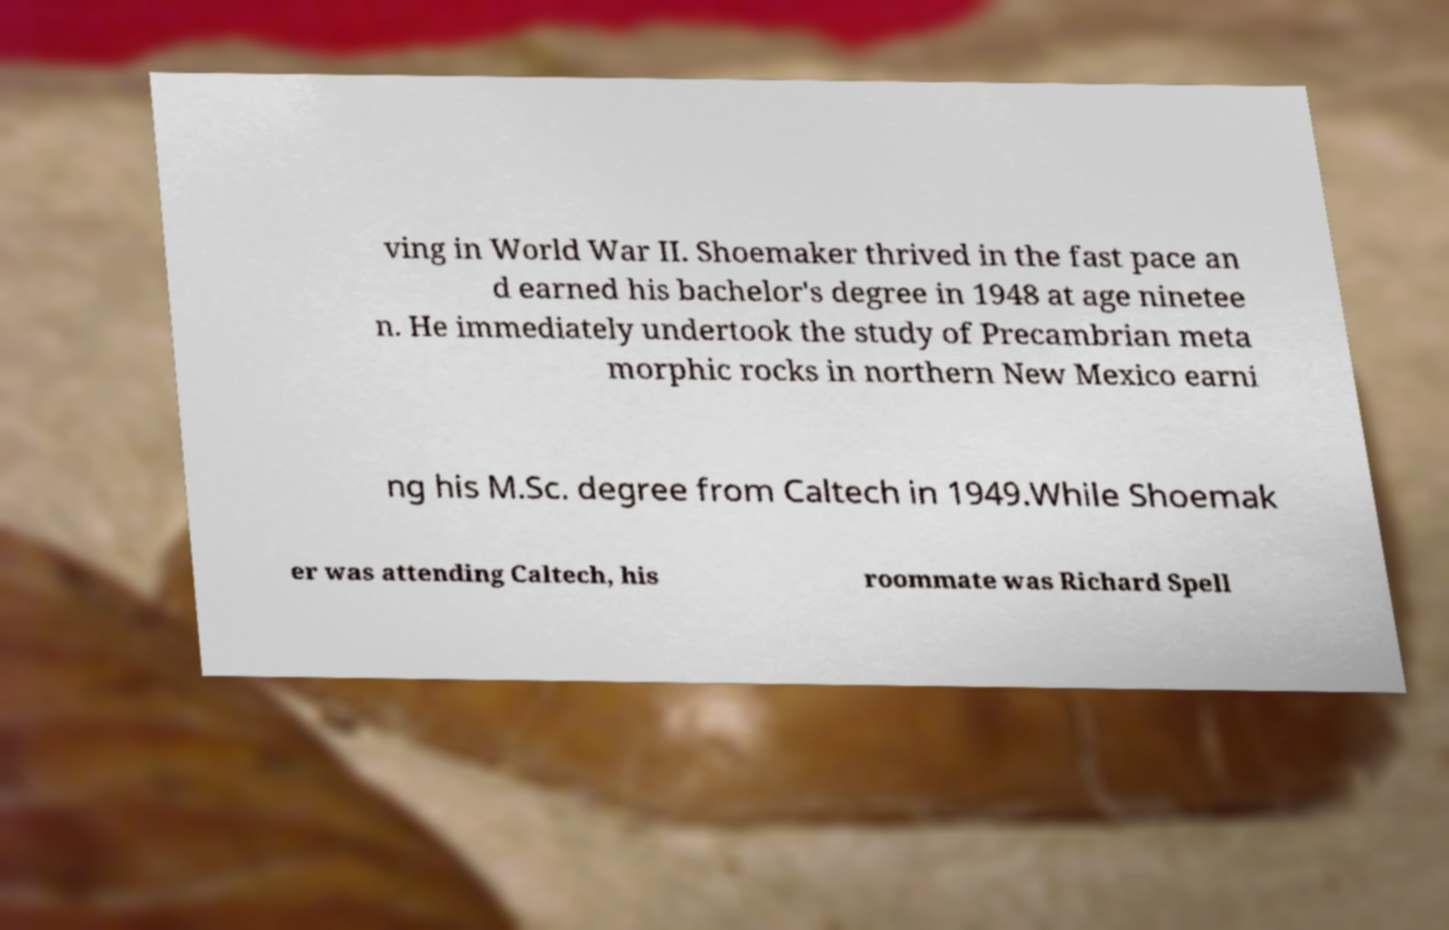For documentation purposes, I need the text within this image transcribed. Could you provide that? ving in World War II. Shoemaker thrived in the fast pace an d earned his bachelor's degree in 1948 at age ninetee n. He immediately undertook the study of Precambrian meta morphic rocks in northern New Mexico earni ng his M.Sc. degree from Caltech in 1949.While Shoemak er was attending Caltech, his roommate was Richard Spell 